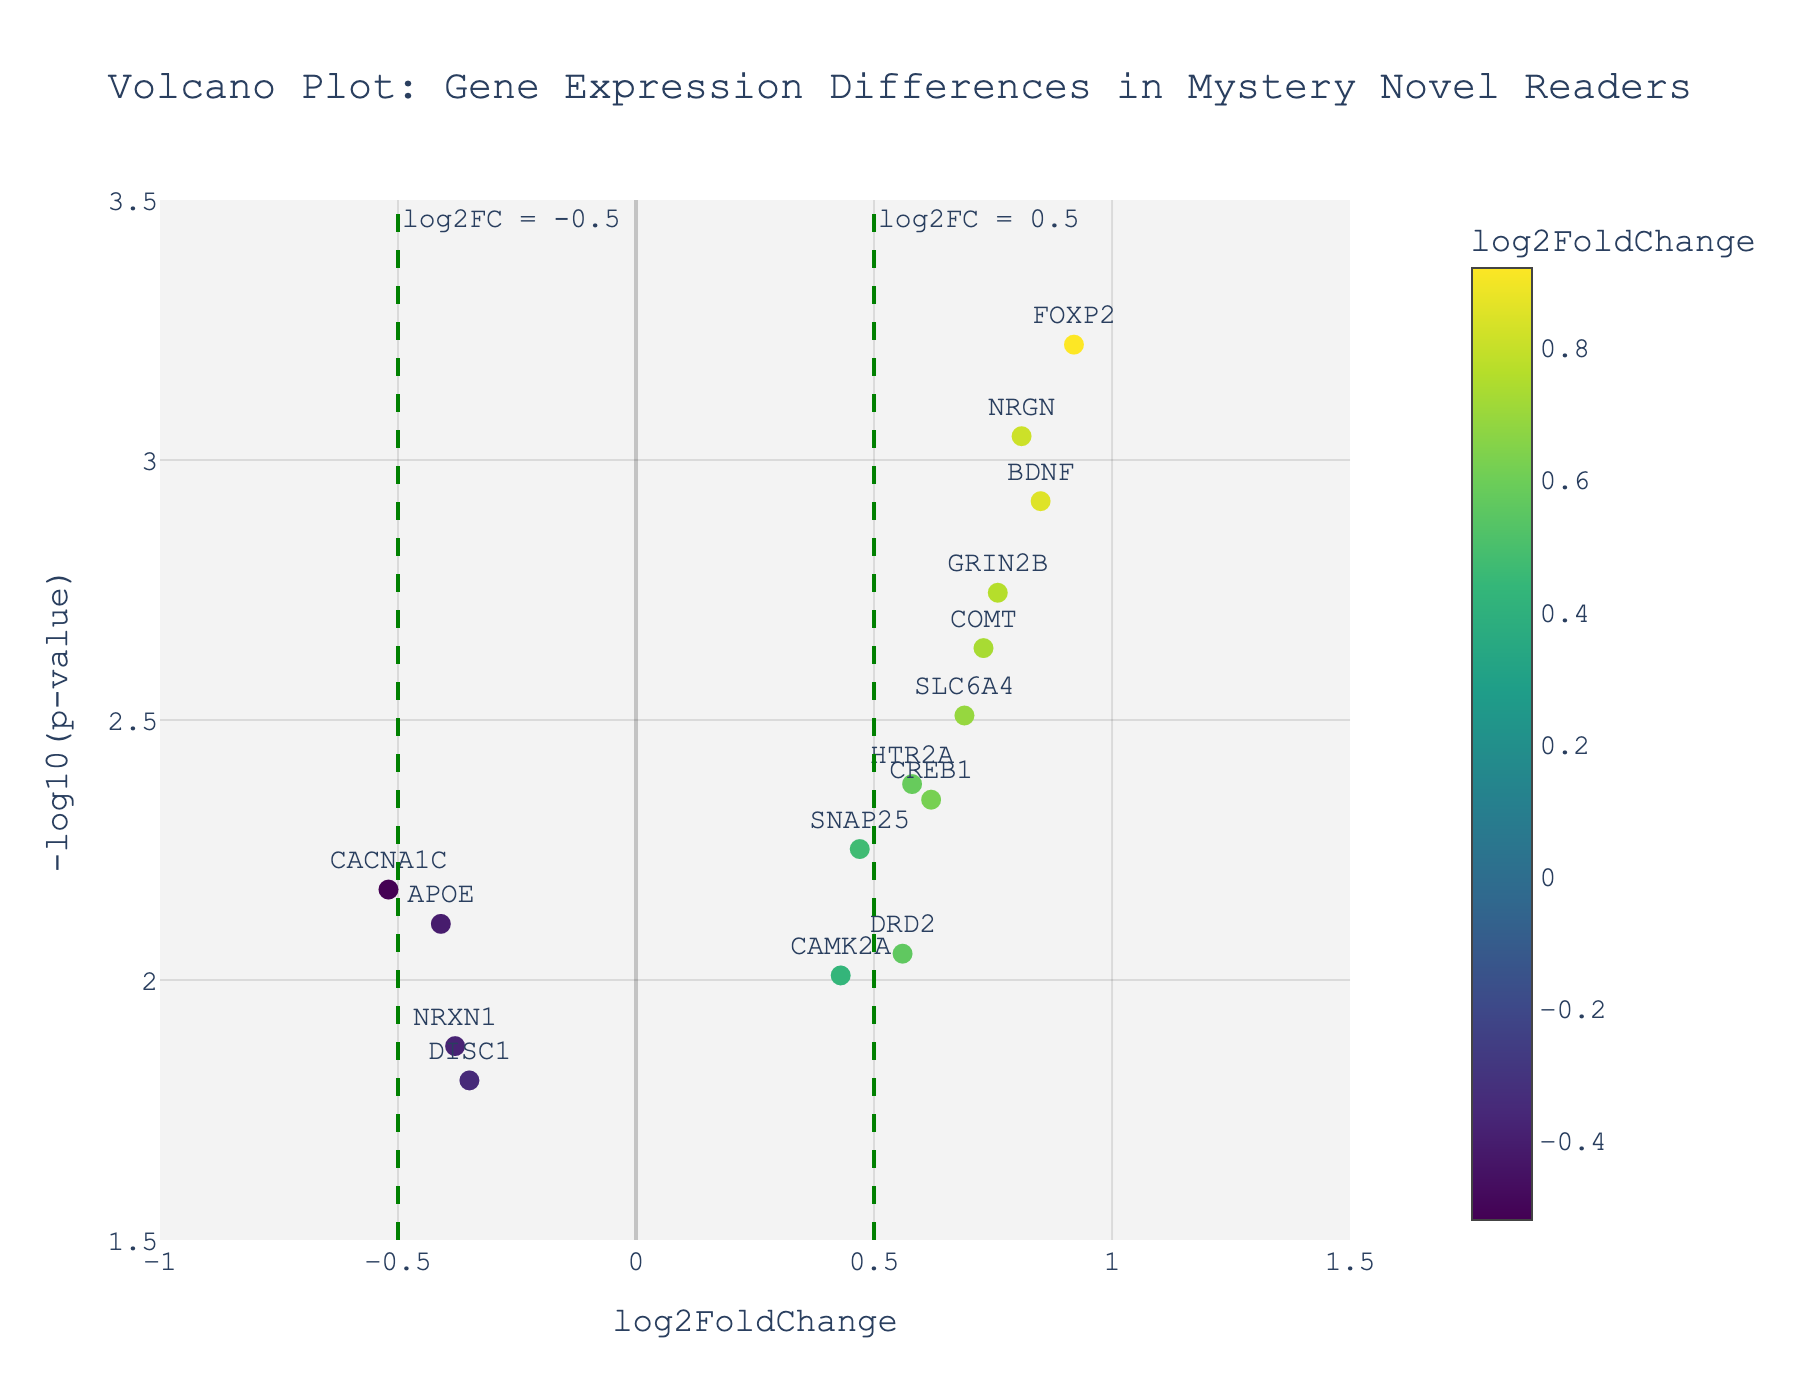How many genes have a log2FoldChange greater than 0.5? First, identify the genes with log2FoldChange values above 0.5 by looking at the x-axis. Then, count these genes from the figure: BDNF, COMT, FOXP2, NRGN, HTR2A, GRIN2B, SLC6A4, and CREB1.
Answer: 8 Which gene has the highest -log10(p-value)? Observe the y-axis for the highest point, then check the label next to this point. The highest point is for the gene FOXP2 with the highest -log10(p-value).
Answer: FOXP2 What is the log2FoldChange and -log10(p-value) of the gene DRD2? Locate the gene name "DRD2" on the plot, then check its corresponding x and y coordinates. DRD2 has a log2FoldChange around 0.56 and -log10(p-value) slightly under 3.
Answer: log2FoldChange: 0.56, -log10(p-value): ~2.95 Are there more genes with positive log2FoldChange or negative log2FoldChange? Compare the number of genes plotted to the right of the y-axis (positive log2FoldChange) to the number of genes to the left (negative log2FoldChange). There are more genes with positive log2FoldChange.
Answer: Positive Which gene has the smallest p-value? Identify the gene with the highest -log10(p-value) since the transform is a negative log scale. The gene FOXP2 has the highest -log10(p-value) and thus the smallest p-value.
Answer: FOXP2 How many genes are statistically significant with a p-value < 0.05? The threshold line for the p-value < 0.05 is shown. Count the number of points above this line. This gives us BDNF, CREB1, COMT, FOXP2, NRGN, HTR2A, GRIN2B, SLC6A4, and DRD2.
Answer: 9 What is the range of log2FoldChange values for the genes in the plot? Observe the x-axis for the lowest and highest log2FoldChange values. The minimum value is around -0.52 (CACNA1C), and the maximum is approximately 0.92 (FOXP2).
Answer: -0.52 to 0.92 Between BDNF and APOE, which gene has a more significant p-value? By checking the -log10(p-value) on the y-axis, BDNF is higher than APOE meaning it has a more significant (smaller) p-value.
Answer: BDNF Which genes are between the log2FoldChange thresholds of -0.5 and 0.5? Look for genes between the two vertical dashed lines at log2FoldChange -0.5 and 0.5. They are APOE, CACNA1C, DRD2, SNAP25, DISC1, and CAMK2A.
Answer: APOE, CACNA1C, DRD2, SNAP25, DISC1, CAMK2A 